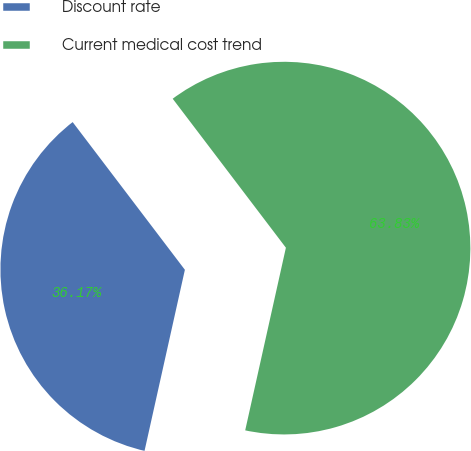<chart> <loc_0><loc_0><loc_500><loc_500><pie_chart><fcel>Discount rate<fcel>Current medical cost trend<nl><fcel>36.17%<fcel>63.83%<nl></chart> 